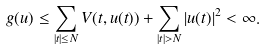Convert formula to latex. <formula><loc_0><loc_0><loc_500><loc_500>g ( u ) \leq \sum _ { | t | \leq N } V ( t , u ( t ) ) + \sum _ { | t | > N } | u ( t ) | ^ { 2 } < \infty .</formula> 